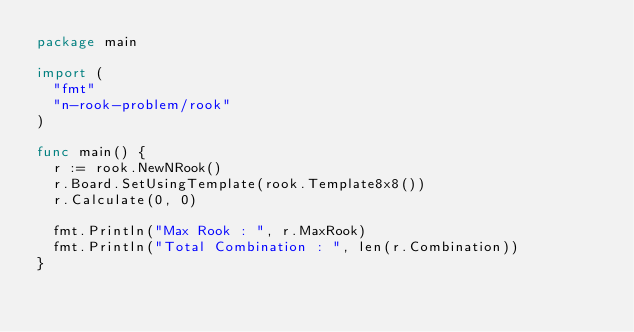<code> <loc_0><loc_0><loc_500><loc_500><_Go_>package main

import (
	"fmt"
	"n-rook-problem/rook"
)

func main() {
	r := rook.NewNRook()
	r.Board.SetUsingTemplate(rook.Template8x8())
	r.Calculate(0, 0)

	fmt.Println("Max Rook : ", r.MaxRook)
	fmt.Println("Total Combination : ", len(r.Combination))
}
</code> 